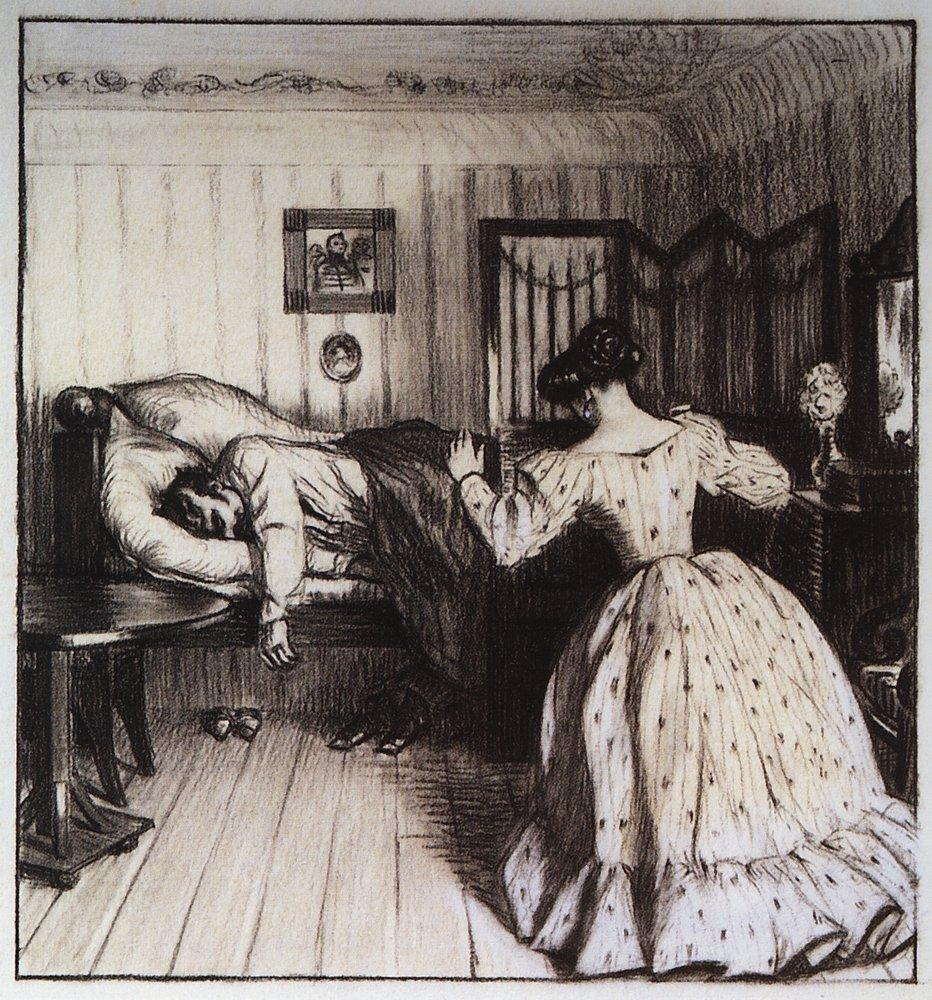What does the choice of decor, such as the flowers and the artworks, suggest about the characters? The tasteful decor in the room, including the vase of flowers and the artworks hanging on the wall, suggests that the characters value beauty and possibly have a comfortable social status. The presence of flowers might symbolize a love for nature and beauty, enhancing the aesthetic appeal of their home. The artworks could indicate a cultural appreciation and personal history, contributing to a more personalized and cherished living space. 